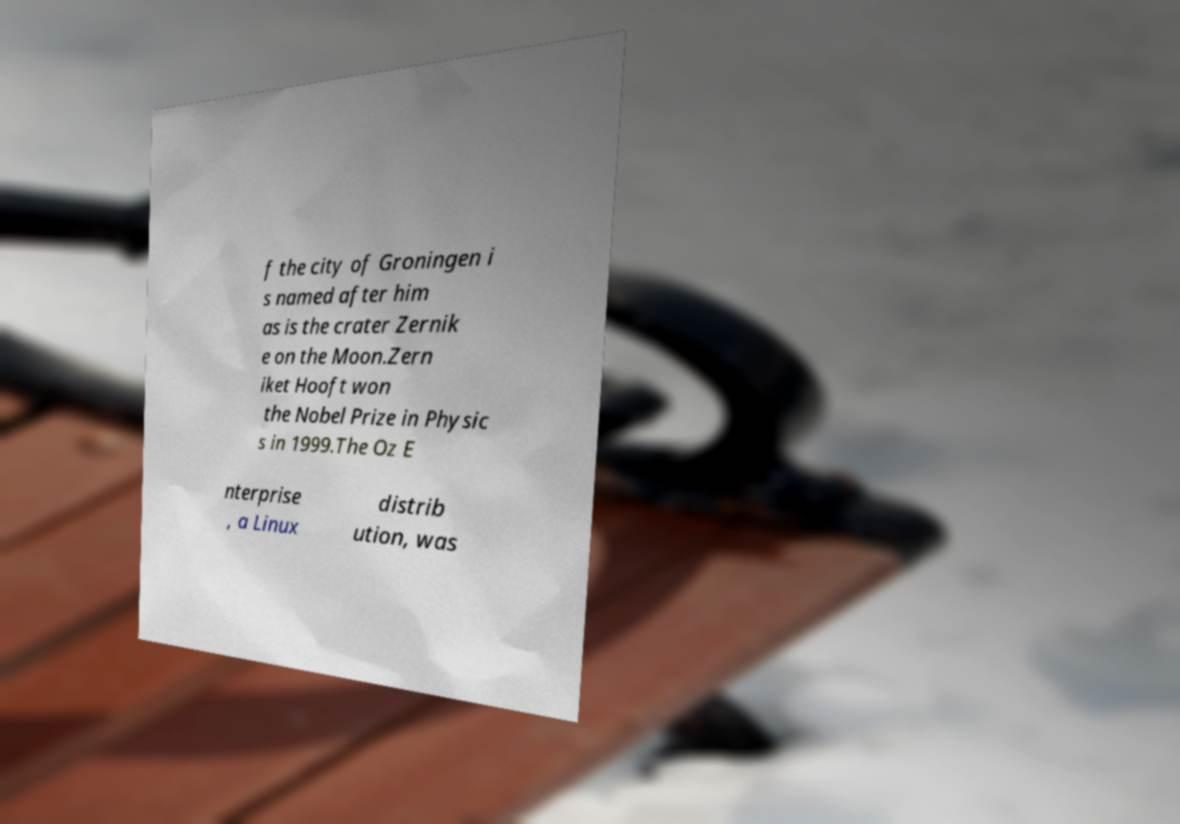I need the written content from this picture converted into text. Can you do that? f the city of Groningen i s named after him as is the crater Zernik e on the Moon.Zern iket Hooft won the Nobel Prize in Physic s in 1999.The Oz E nterprise , a Linux distrib ution, was 